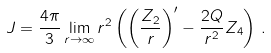Convert formula to latex. <formula><loc_0><loc_0><loc_500><loc_500>J & = \frac { 4 \pi } { 3 } \lim _ { r \to \infty } r ^ { 2 } \left ( \left ( \frac { Z _ { 2 } } { r } \right ) ^ { \prime } - \frac { 2 Q } { r ^ { 2 } } Z _ { 4 } \right ) \, .</formula> 